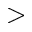<formula> <loc_0><loc_0><loc_500><loc_500>></formula> 